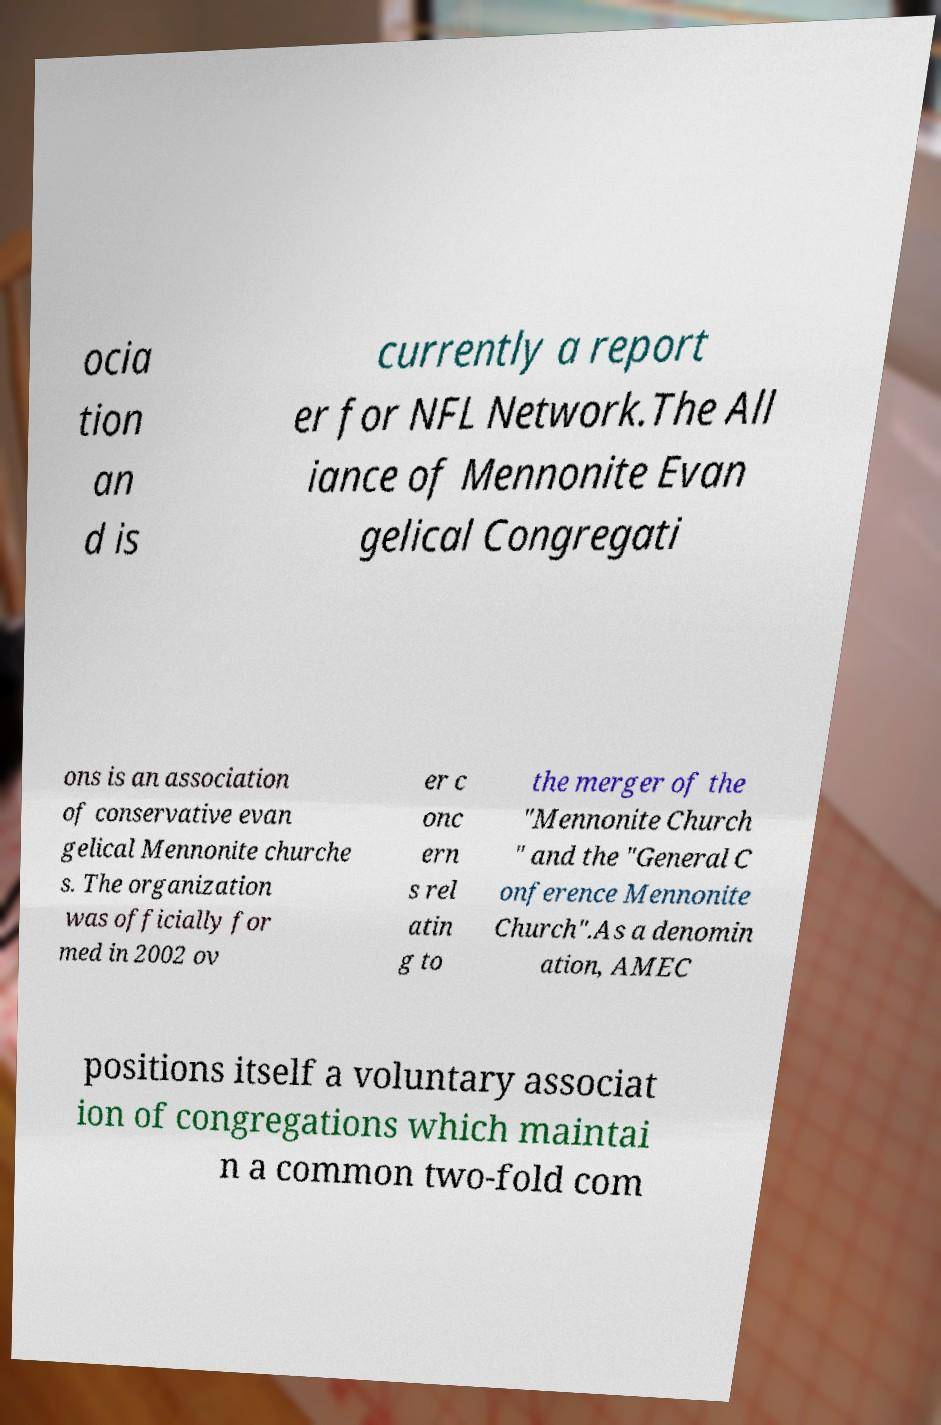What messages or text are displayed in this image? I need them in a readable, typed format. ocia tion an d is currently a report er for NFL Network.The All iance of Mennonite Evan gelical Congregati ons is an association of conservative evan gelical Mennonite churche s. The organization was officially for med in 2002 ov er c onc ern s rel atin g to the merger of the "Mennonite Church " and the "General C onference Mennonite Church".As a denomin ation, AMEC positions itself a voluntary associat ion of congregations which maintai n a common two-fold com 